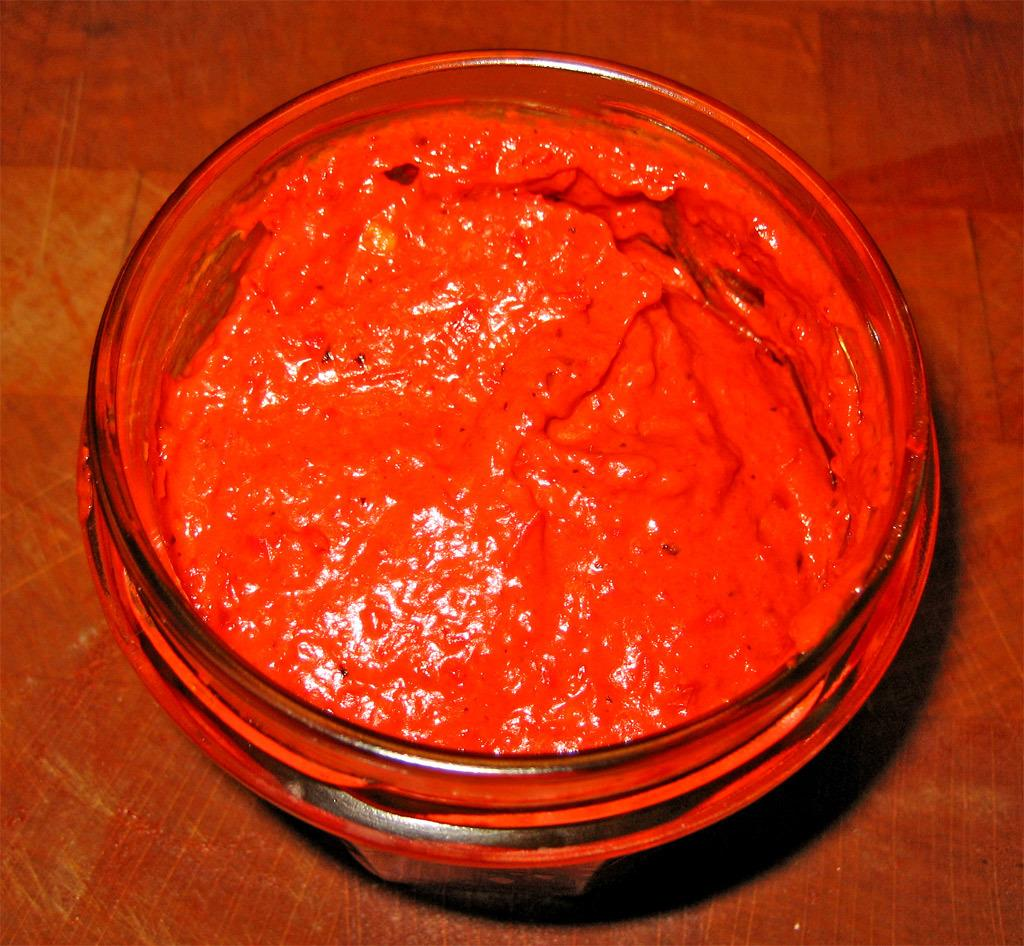What is the main object in the image? There is a container in the image. What is inside the container? The container is filled with a semi-solid substance. On what surface is the container placed? The container is placed on a wooden surface. What type of scarecrow is standing next to the container in the image? There is no scarecrow present in the image. What offer is being made by the container in the image? The container is not making any offer; it is simply holding a semi-solid substance. 